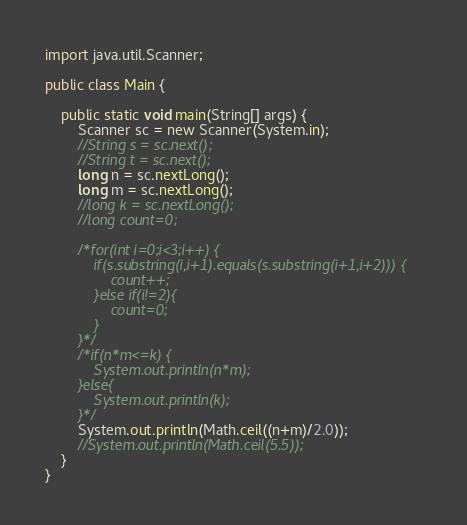<code> <loc_0><loc_0><loc_500><loc_500><_Java_>import java.util.Scanner;

public class Main {

	public static void main(String[] args) {
		Scanner sc = new Scanner(System.in);
		//String s = sc.next();
		//String t = sc.next();
		long n = sc.nextLong();
		long m = sc.nextLong();
		//long k = sc.nextLong();
		//long count=0;

		/*for(int i=0;i<3;i++) {
			if(s.substring(i,i+1).equals(s.substring(i+1,i+2))) {
				count++;
			}else if(i!=2){
				count=0;
			}
		}*/
		/*if(n*m<=k) {
			System.out.println(n*m);
		}else{
			System.out.println(k);
		}*/
		System.out.println(Math.ceil((n+m)/2.0));
		//System.out.println(Math.ceil(5.5));
	}
}


</code> 